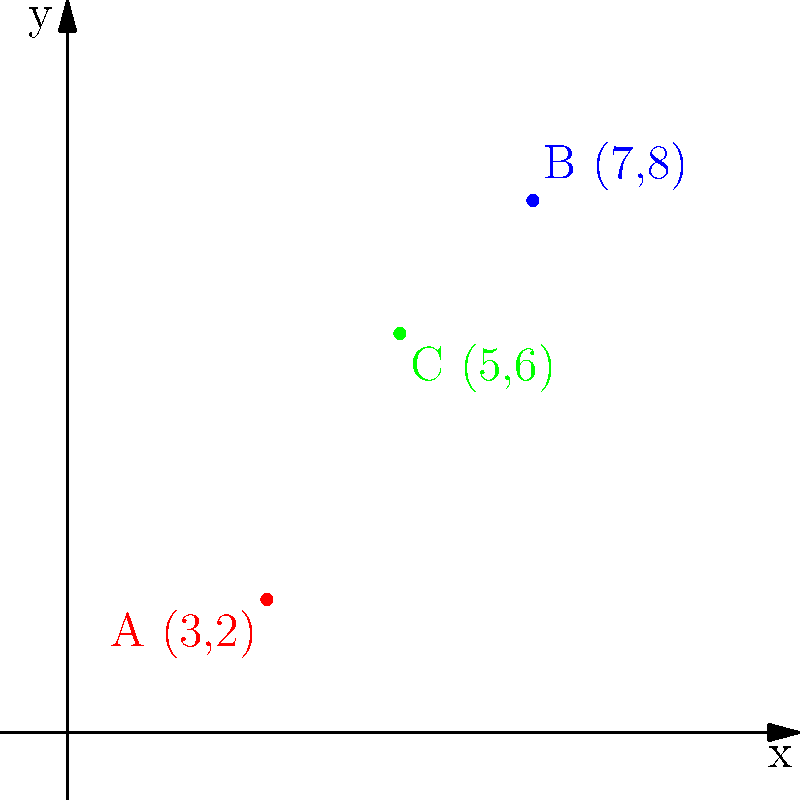As a weather forecaster, you're mapping severe weather warnings on a Cartesian grid. Three storm cells are identified at points A(3,2), B(7,8), and C(5,6). What is the total distance, rounded to the nearest whole number, that an emergency response team would need to travel to visit all three locations in the order A to B to C, assuming they can move in straight lines? To solve this problem, we need to calculate the distances between the points and sum them up. We'll use the distance formula between two points: $d = \sqrt{(x_2-x_1)^2 + (y_2-y_1)^2}$

Step 1: Calculate distance from A to B
$d_{AB} = \sqrt{(7-3)^2 + (8-2)^2} = \sqrt{4^2 + 6^2} = \sqrt{16 + 36} = \sqrt{52} \approx 7.21$ units

Step 2: Calculate distance from B to C
$d_{BC} = \sqrt{(5-7)^2 + (6-8)^2} = \sqrt{(-2)^2 + (-2)^2} = \sqrt{4 + 4} = \sqrt{8} \approx 2.83$ units

Step 3: Sum up the distances
Total distance = $d_{AB} + d_{BC} = 7.21 + 2.83 = 10.04$ units

Step 4: Round to the nearest whole number
10.04 rounds to 10

Therefore, the total distance the emergency response team would need to travel is approximately 10 units.
Answer: 10 units 